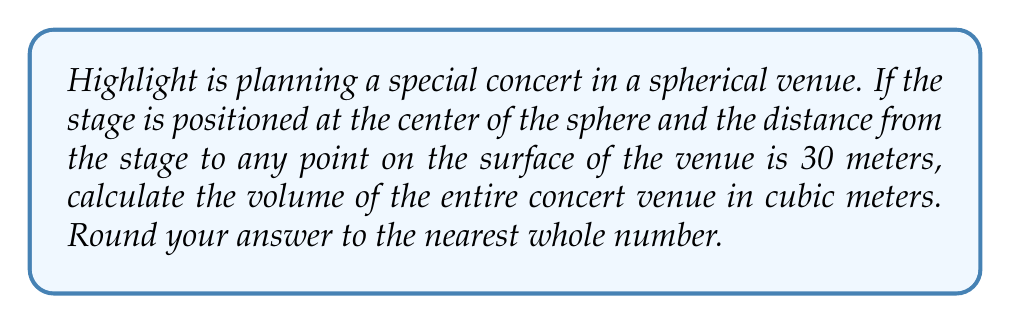Can you solve this math problem? Let's approach this step-by-step:

1) The distance from the center to any point on the surface of a sphere is its radius. So, the radius of our spherical concert venue is 30 meters.

2) The formula for the volume of a sphere is:

   $$V = \frac{4}{3}\pi r^3$$

   Where $V$ is the volume and $r$ is the radius.

3) Let's substitute our known value:

   $$V = \frac{4}{3}\pi (30)^3$$

4) Now, let's calculate:

   $$V = \frac{4}{3}\pi \cdot 27000$$

5) Simplify:

   $$V = 36000\pi$$

6) Using 3.14159 as an approximation for $\pi$:

   $$V \approx 36000 \cdot 3.14159 = 113097.24$$

7) Rounding to the nearest whole number:

   $$V \approx 113097 \text{ cubic meters}$$
Answer: 113097 cubic meters 